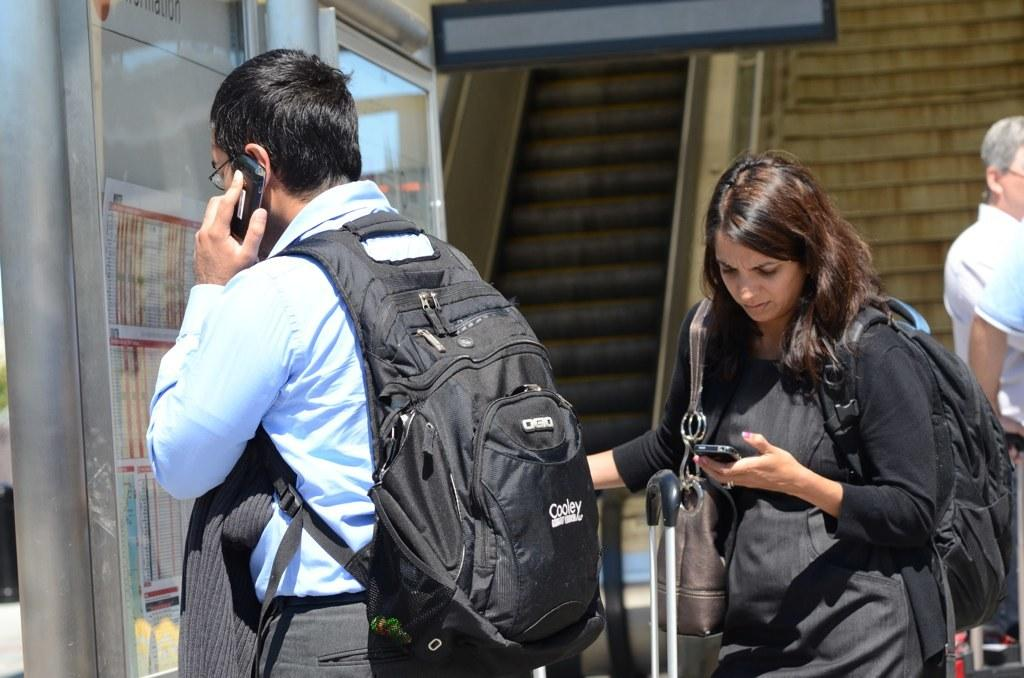<image>
Offer a succinct explanation of the picture presented. Man and Woman using their smartphones, The man has a Cooley backpack. 